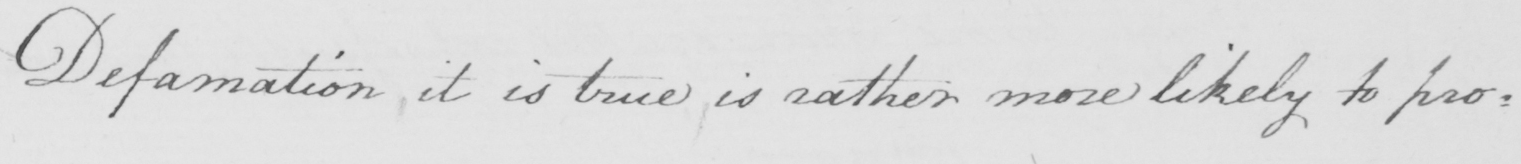Please provide the text content of this handwritten line. Defamation , it is true , is rather more likely to pro= 